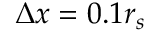Convert formula to latex. <formula><loc_0><loc_0><loc_500><loc_500>\Delta x = 0 . 1 r _ { s }</formula> 